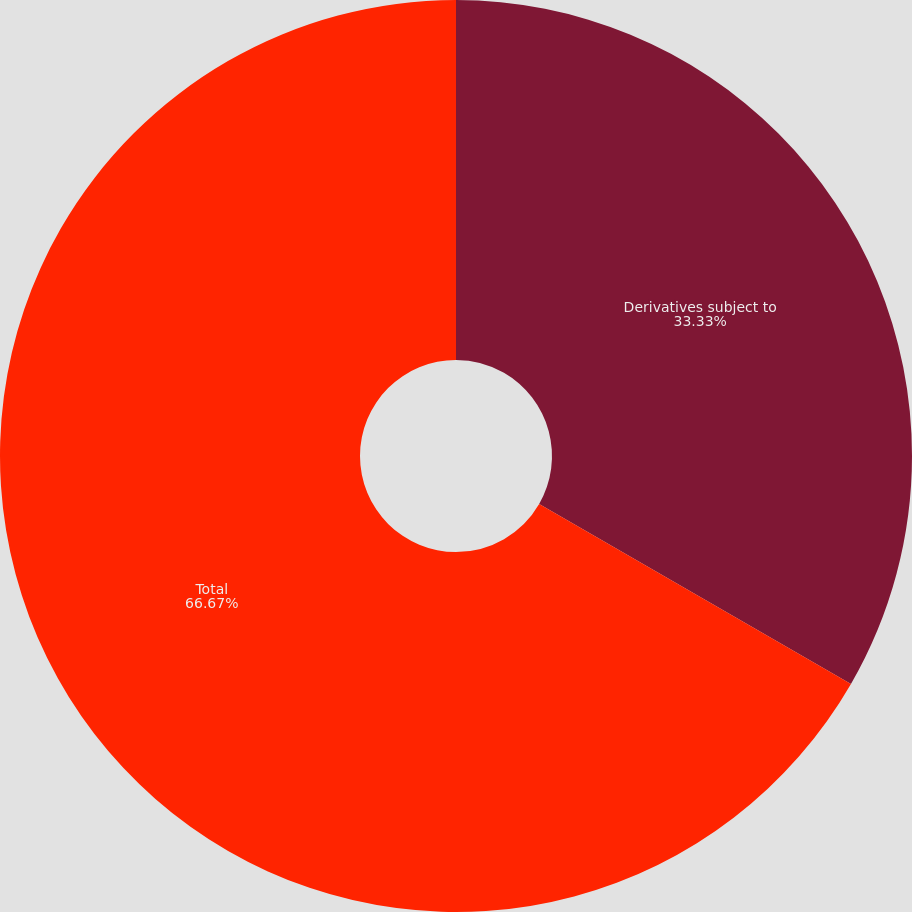<chart> <loc_0><loc_0><loc_500><loc_500><pie_chart><fcel>Derivatives subject to<fcel>Total<nl><fcel>33.33%<fcel>66.67%<nl></chart> 